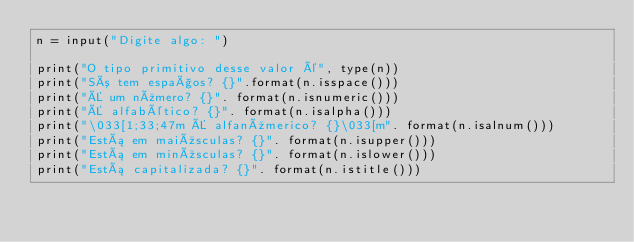<code> <loc_0><loc_0><loc_500><loc_500><_Python_>n = input("Digite algo: ")

print("O tipo primitivo desse valor é", type(n))
print("Só tem espaços? {}".format(n.isspace()))
print("É um número? {}". format(n.isnumeric()))
print("É alfabético? {}". format(n.isalpha()))
print("\033[1;33;47m É alfanúmerico? {}\033[m". format(n.isalnum()))
print("Está em maiúsculas? {}". format(n.isupper()))
print("Está em minúsculas? {}". format(n.islower()))
print("Está capitalizada? {}". format(n.istitle()))</code> 